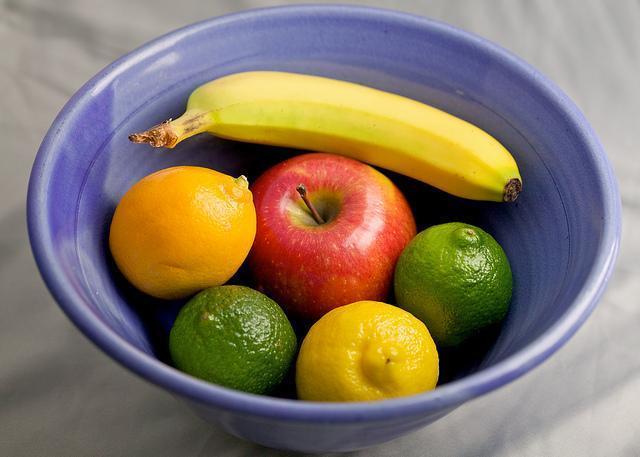How many limes?
Give a very brief answer. 2. How many limes are there?
Give a very brief answer. 2. How many big limes?
Give a very brief answer. 2. How many people are crossing the street?
Give a very brief answer. 0. 